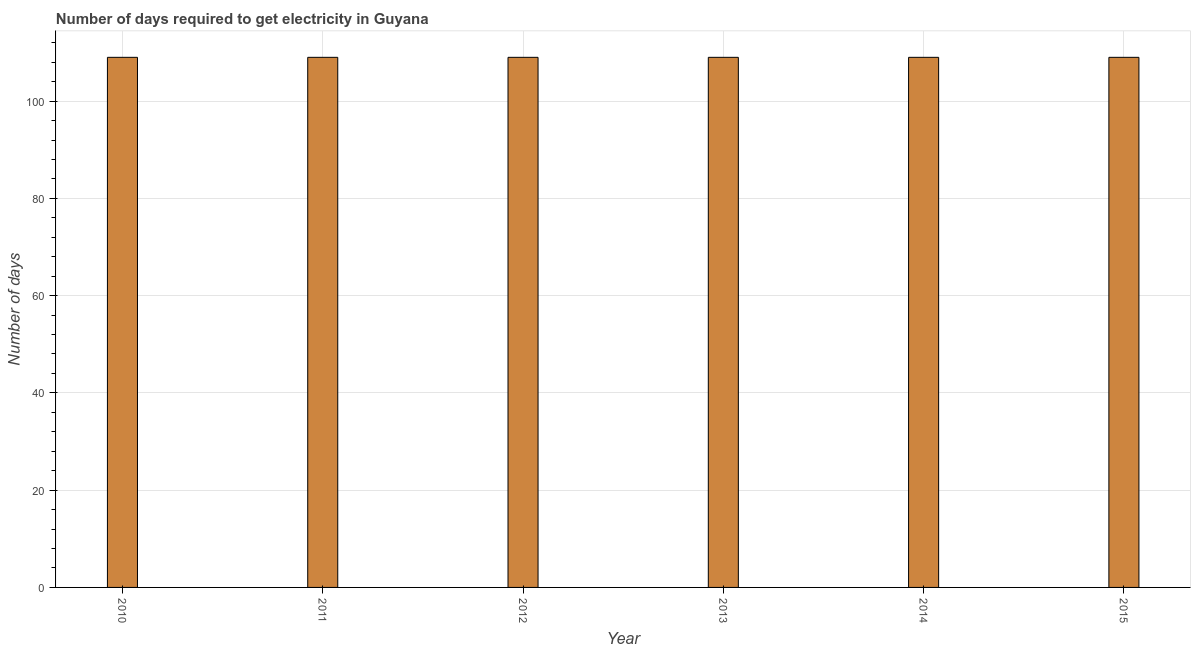Does the graph contain any zero values?
Give a very brief answer. No. What is the title of the graph?
Ensure brevity in your answer.  Number of days required to get electricity in Guyana. What is the label or title of the Y-axis?
Offer a terse response. Number of days. What is the time to get electricity in 2012?
Offer a very short reply. 109. Across all years, what is the maximum time to get electricity?
Offer a terse response. 109. Across all years, what is the minimum time to get electricity?
Your answer should be compact. 109. What is the sum of the time to get electricity?
Keep it short and to the point. 654. What is the average time to get electricity per year?
Your answer should be very brief. 109. What is the median time to get electricity?
Your response must be concise. 109. What is the ratio of the time to get electricity in 2010 to that in 2015?
Make the answer very short. 1. Is the difference between the time to get electricity in 2013 and 2015 greater than the difference between any two years?
Offer a very short reply. Yes. What is the difference between the highest and the second highest time to get electricity?
Provide a succinct answer. 0. What is the difference between the highest and the lowest time to get electricity?
Ensure brevity in your answer.  0. What is the difference between two consecutive major ticks on the Y-axis?
Your answer should be very brief. 20. What is the Number of days of 2010?
Provide a short and direct response. 109. What is the Number of days of 2011?
Your response must be concise. 109. What is the Number of days in 2012?
Your response must be concise. 109. What is the Number of days of 2013?
Ensure brevity in your answer.  109. What is the Number of days of 2014?
Make the answer very short. 109. What is the Number of days in 2015?
Provide a succinct answer. 109. What is the difference between the Number of days in 2010 and 2011?
Your answer should be very brief. 0. What is the difference between the Number of days in 2010 and 2013?
Give a very brief answer. 0. What is the difference between the Number of days in 2010 and 2014?
Offer a very short reply. 0. What is the difference between the Number of days in 2011 and 2013?
Your response must be concise. 0. What is the difference between the Number of days in 2011 and 2014?
Your response must be concise. 0. What is the difference between the Number of days in 2011 and 2015?
Offer a terse response. 0. What is the difference between the Number of days in 2013 and 2014?
Make the answer very short. 0. What is the difference between the Number of days in 2013 and 2015?
Keep it short and to the point. 0. What is the ratio of the Number of days in 2012 to that in 2013?
Make the answer very short. 1. 